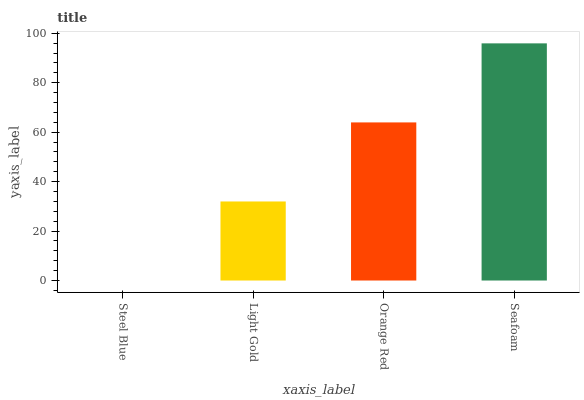Is Steel Blue the minimum?
Answer yes or no. Yes. Is Seafoam the maximum?
Answer yes or no. Yes. Is Light Gold the minimum?
Answer yes or no. No. Is Light Gold the maximum?
Answer yes or no. No. Is Light Gold greater than Steel Blue?
Answer yes or no. Yes. Is Steel Blue less than Light Gold?
Answer yes or no. Yes. Is Steel Blue greater than Light Gold?
Answer yes or no. No. Is Light Gold less than Steel Blue?
Answer yes or no. No. Is Orange Red the high median?
Answer yes or no. Yes. Is Light Gold the low median?
Answer yes or no. Yes. Is Steel Blue the high median?
Answer yes or no. No. Is Orange Red the low median?
Answer yes or no. No. 